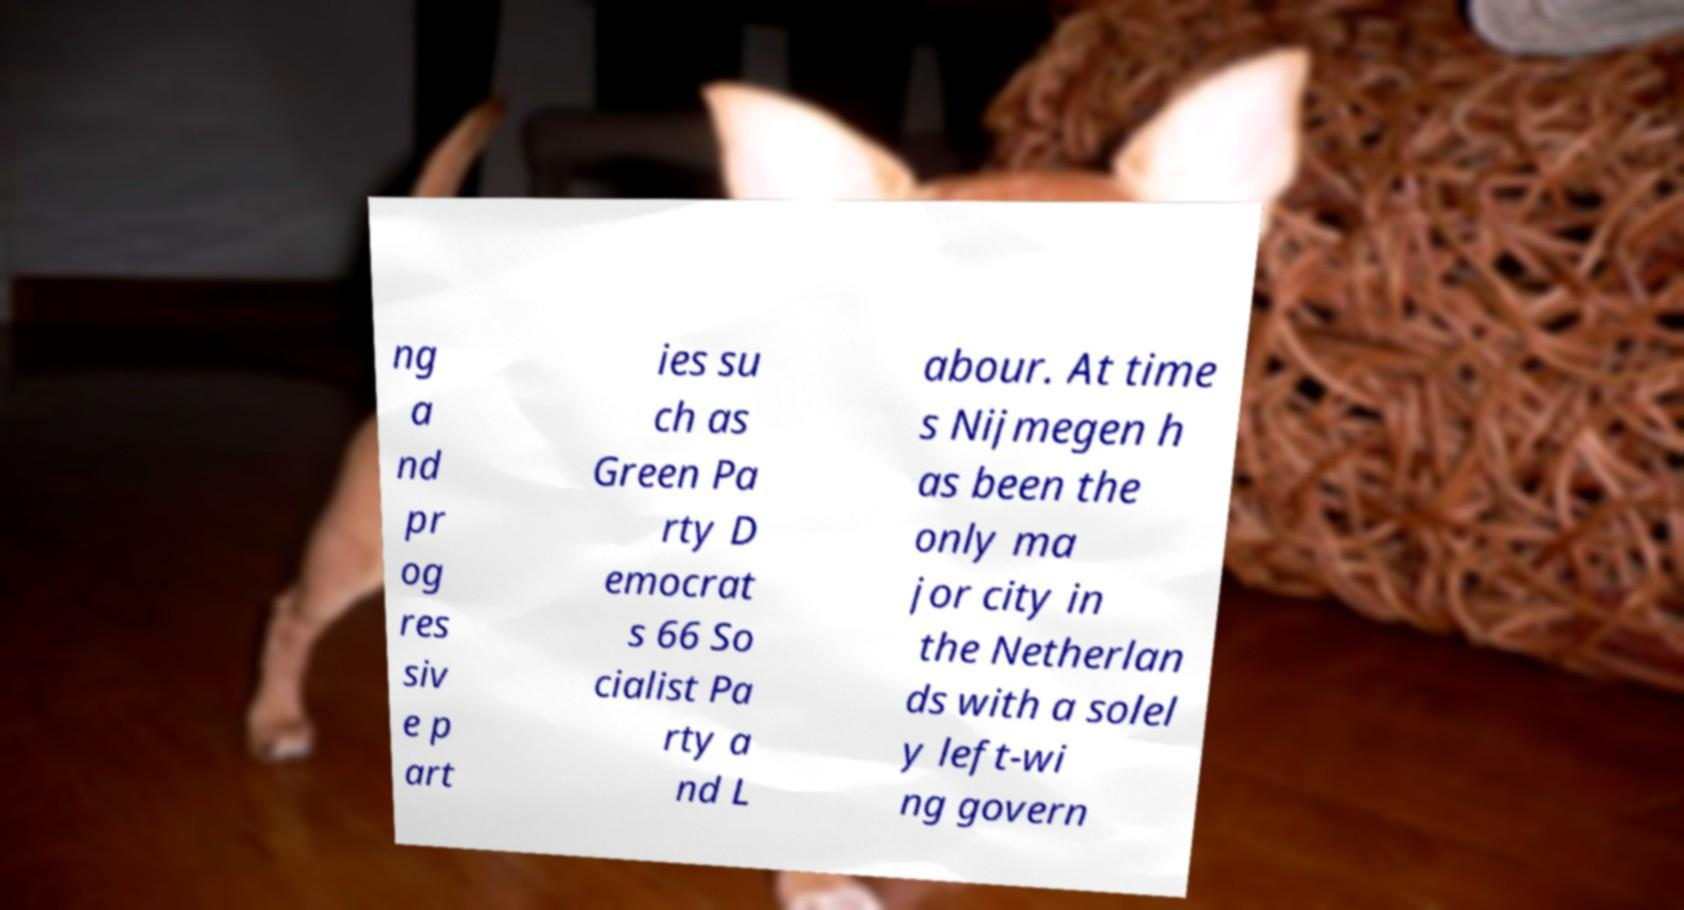Could you extract and type out the text from this image? ng a nd pr og res siv e p art ies su ch as Green Pa rty D emocrat s 66 So cialist Pa rty a nd L abour. At time s Nijmegen h as been the only ma jor city in the Netherlan ds with a solel y left-wi ng govern 